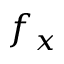<formula> <loc_0><loc_0><loc_500><loc_500>f _ { x }</formula> 